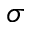Convert formula to latex. <formula><loc_0><loc_0><loc_500><loc_500>\sigma</formula> 